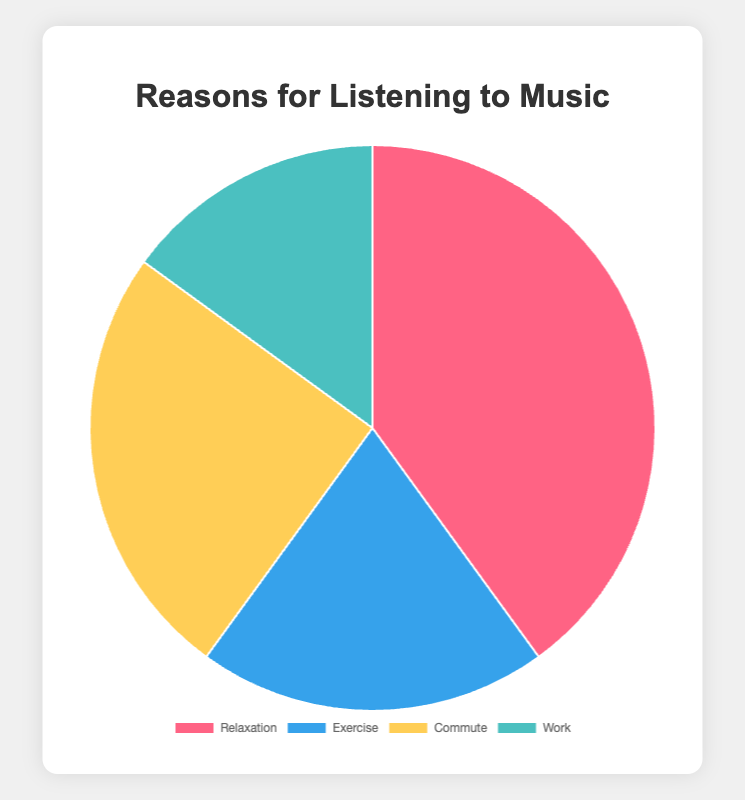What is the most common reason people listen to music? The chart shows the percentages for each reason. The largest percentage corresponds to 'Relaxation' at 40%.
Answer: Relaxation Which reason accounts for the smallest percentage of why people listen to music? By examining the percentages, 'Work' has the smallest share, with 15%.
Answer: Work What is the combined percentage of people who listen to music for Exercise and Commute? The percentages for Exercise and Commute are 20% and 25%, respectively. Adding them together gives 45%.
Answer: 45% How much greater is the percentage of people who listen to music for Relaxation compared to those who do so for Work? The percentage for Relaxation is 40%, and for Work, it's 15%. The difference is 40% - 15% = 25%.
Answer: 25% Which reasons collectively account for more than half of the reasons people listen to music? Summing up the highest percentages, 40% for Relaxation and 25% for Commute, we get 65%, which is more than half.
Answer: Relaxation and Commute What is the difference between the percentage of people who listen to music during Commute and those who listen to it while Exercising? The percentage for Commute is 25% and for Exercise, it is 20%. The difference is 25% - 20% = 5%.
Answer: 5% What is the average percentage of the reasons for listening to music given? Adding all the percentages: 40% (Relaxation) + 20% (Exercise) + 25% (Commute) + 15% (Work) gives 100%. Dividing by the four reasons, the average is 100% / 4 = 25%.
Answer: 25% Which colors represent Relaxation and Work in the pie chart? From the chart, Relaxation is depicted in red, and Work is shown in a greenish-blue.
Answer: Red and greenish-blue Is the percentage of people who listen to music while working less than those who listen for exercise? The chart shows 15% for Work and 20% for Exercise, making Work less than Exercise.
Answer: Yes By how much is the percentage of people who listen to music to relax more than the combined percentage of those who do so for Work and Exercise? Relaxation is at 40%, while Work and Exercise together are 15% + 20% = 35%. The difference is 40% - 35% = 5%.
Answer: 5% 